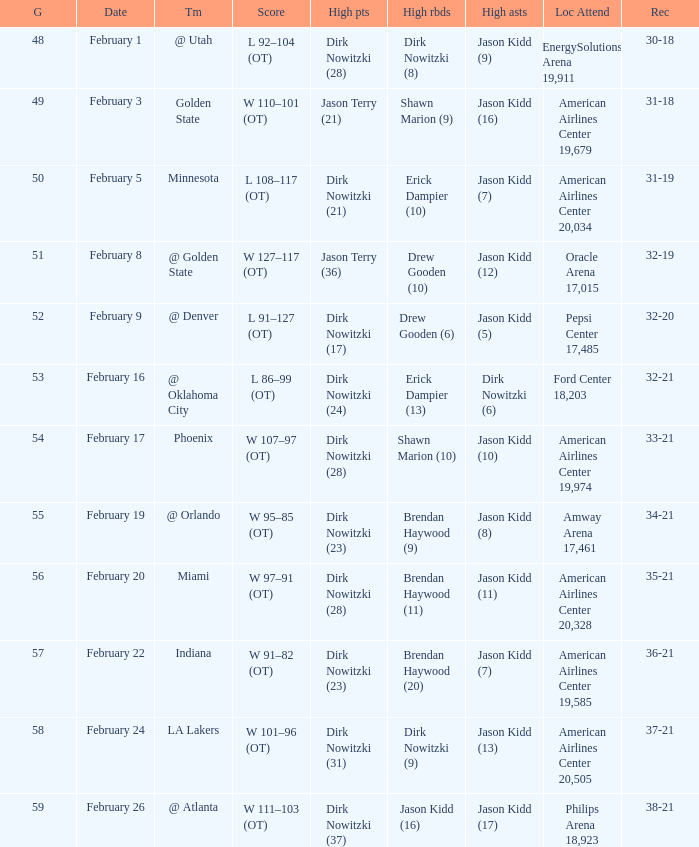When did the Mavericks have a record of 32-19? February 8. 